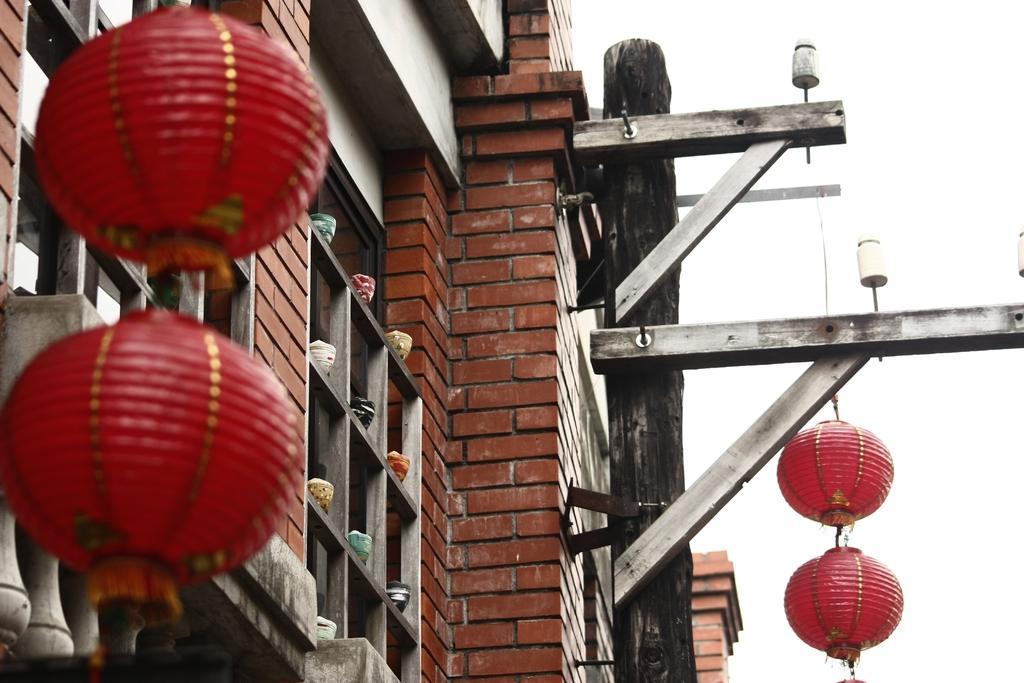Could you give a brief overview of what you see in this image? There are red colored lanterns attached to the threads. In the background, there is a building which is having brick wall and glass windows and there is sky. 